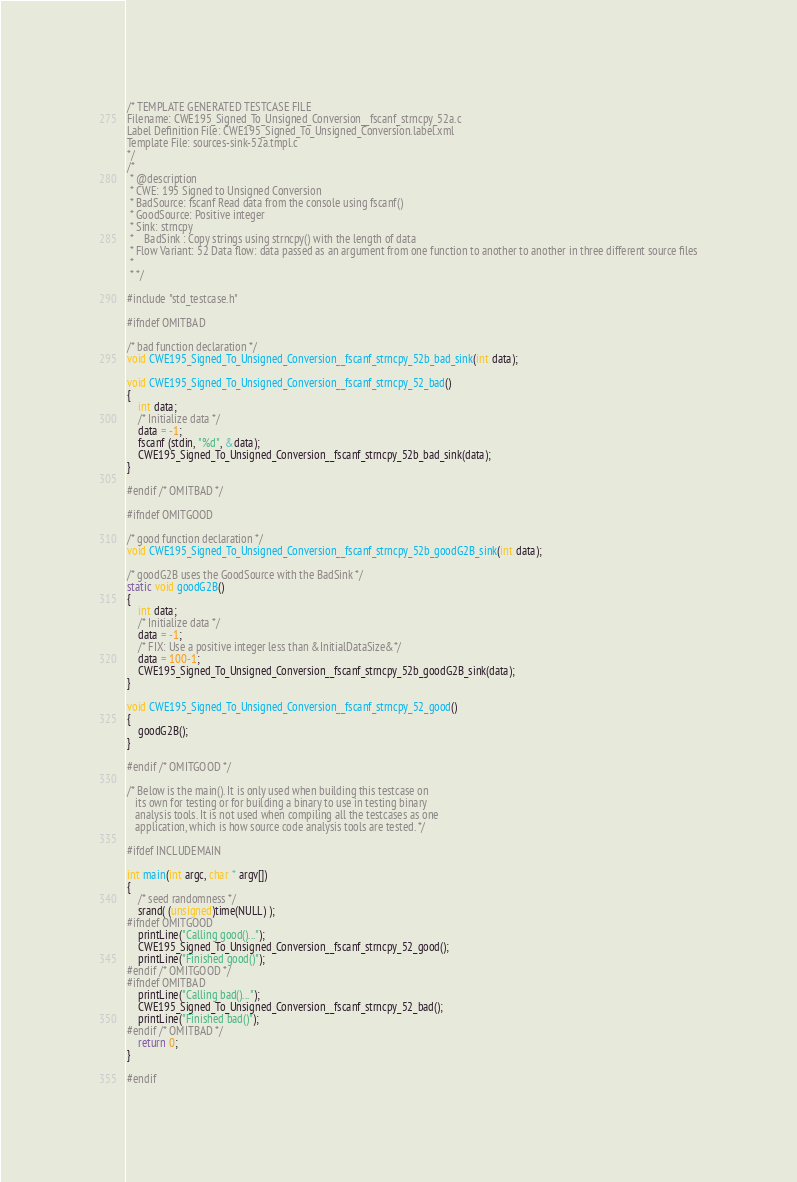<code> <loc_0><loc_0><loc_500><loc_500><_C_>/* TEMPLATE GENERATED TESTCASE FILE
Filename: CWE195_Signed_To_Unsigned_Conversion__fscanf_strncpy_52a.c
Label Definition File: CWE195_Signed_To_Unsigned_Conversion.label.xml
Template File: sources-sink-52a.tmpl.c
*/
/*
 * @description
 * CWE: 195 Signed to Unsigned Conversion
 * BadSource: fscanf Read data from the console using fscanf()
 * GoodSource: Positive integer
 * Sink: strncpy
 *    BadSink : Copy strings using strncpy() with the length of data
 * Flow Variant: 52 Data flow: data passed as an argument from one function to another to another in three different source files
 *
 * */

#include "std_testcase.h"

#ifndef OMITBAD

/* bad function declaration */
void CWE195_Signed_To_Unsigned_Conversion__fscanf_strncpy_52b_bad_sink(int data);

void CWE195_Signed_To_Unsigned_Conversion__fscanf_strncpy_52_bad()
{
    int data;
    /* Initialize data */
    data = -1;
    fscanf (stdin, "%d", &data);
    CWE195_Signed_To_Unsigned_Conversion__fscanf_strncpy_52b_bad_sink(data);
}

#endif /* OMITBAD */

#ifndef OMITGOOD

/* good function declaration */
void CWE195_Signed_To_Unsigned_Conversion__fscanf_strncpy_52b_goodG2B_sink(int data);

/* goodG2B uses the GoodSource with the BadSink */
static void goodG2B()
{
    int data;
    /* Initialize data */
    data = -1;
    /* FIX: Use a positive integer less than &InitialDataSize&*/
    data = 100-1;
    CWE195_Signed_To_Unsigned_Conversion__fscanf_strncpy_52b_goodG2B_sink(data);
}

void CWE195_Signed_To_Unsigned_Conversion__fscanf_strncpy_52_good()
{
    goodG2B();
}

#endif /* OMITGOOD */

/* Below is the main(). It is only used when building this testcase on
   its own for testing or for building a binary to use in testing binary
   analysis tools. It is not used when compiling all the testcases as one
   application, which is how source code analysis tools are tested. */

#ifdef INCLUDEMAIN

int main(int argc, char * argv[])
{
    /* seed randomness */
    srand( (unsigned)time(NULL) );
#ifndef OMITGOOD
    printLine("Calling good()...");
    CWE195_Signed_To_Unsigned_Conversion__fscanf_strncpy_52_good();
    printLine("Finished good()");
#endif /* OMITGOOD */
#ifndef OMITBAD
    printLine("Calling bad()...");
    CWE195_Signed_To_Unsigned_Conversion__fscanf_strncpy_52_bad();
    printLine("Finished bad()");
#endif /* OMITBAD */
    return 0;
}

#endif
</code> 